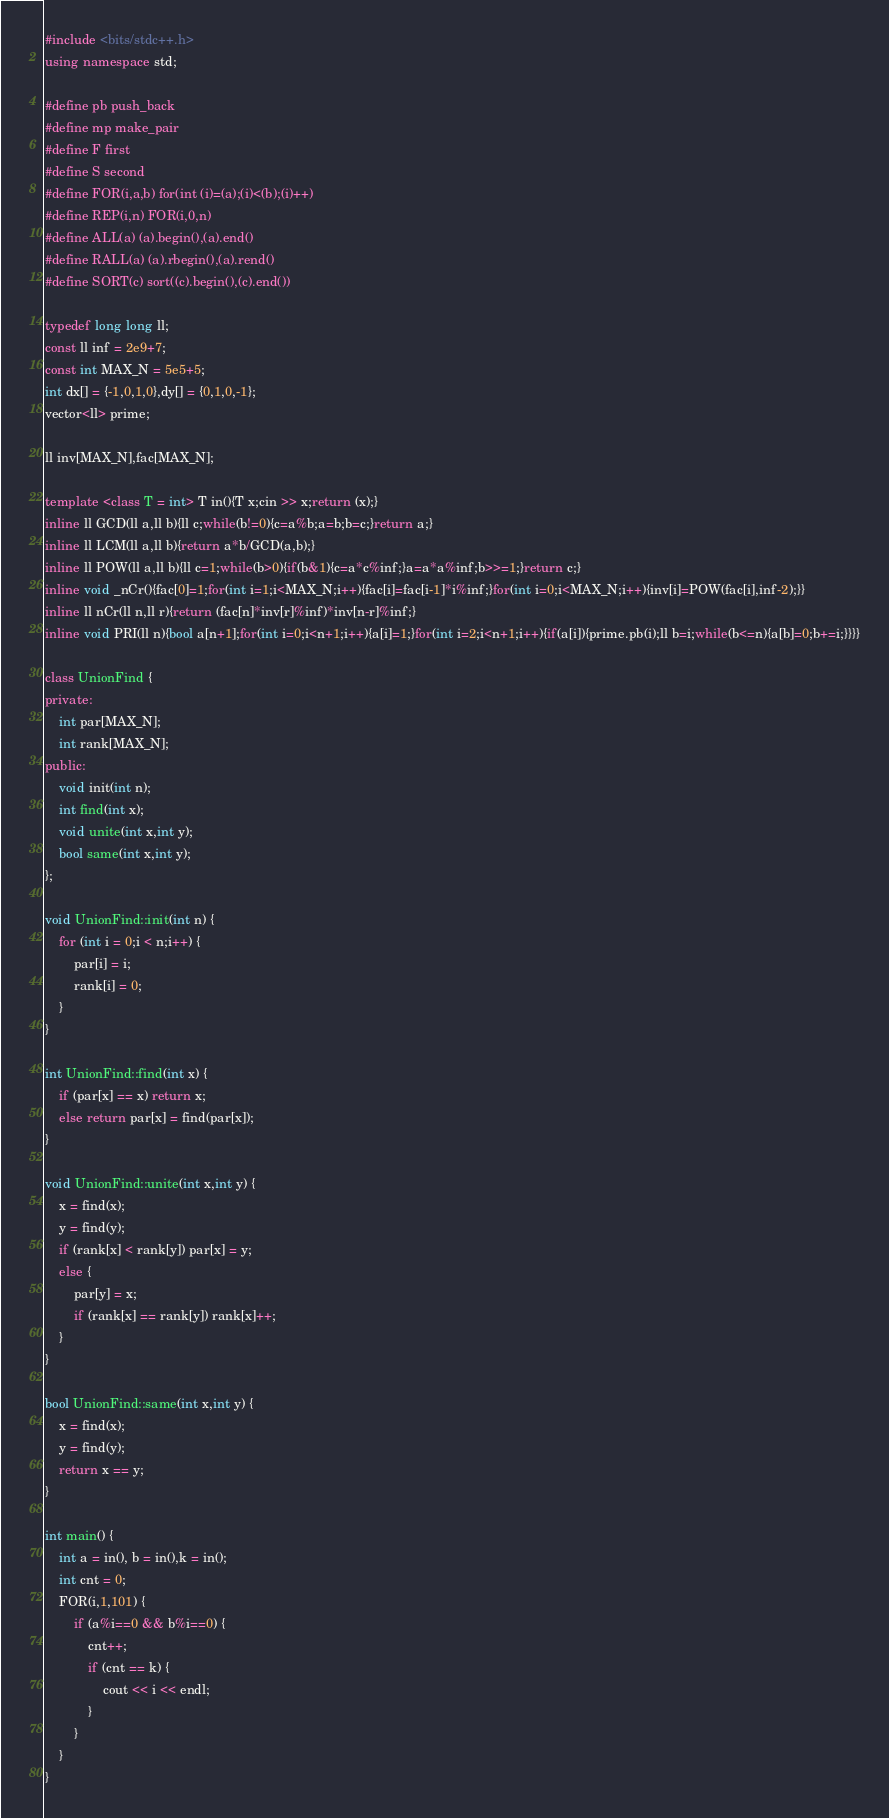<code> <loc_0><loc_0><loc_500><loc_500><_C++_>#include <bits/stdc++.h>
using namespace std;

#define pb push_back
#define mp make_pair
#define F first
#define S second
#define FOR(i,a,b) for(int (i)=(a);(i)<(b);(i)++)
#define REP(i,n) FOR(i,0,n)
#define ALL(a) (a).begin(),(a).end()
#define RALL(a) (a).rbegin(),(a).rend()
#define SORT(c) sort((c).begin(),(c).end())

typedef long long ll;
const ll inf = 2e9+7;
const int MAX_N = 5e5+5;
int dx[] = {-1,0,1,0},dy[] = {0,1,0,-1};
vector<ll> prime;

ll inv[MAX_N],fac[MAX_N];

template <class T = int> T in(){T x;cin >> x;return (x);}
inline ll GCD(ll a,ll b){ll c;while(b!=0){c=a%b;a=b;b=c;}return a;}
inline ll LCM(ll a,ll b){return a*b/GCD(a,b);}
inline ll POW(ll a,ll b){ll c=1;while(b>0){if(b&1){c=a*c%inf;}a=a*a%inf;b>>=1;}return c;}
inline void _nCr(){fac[0]=1;for(int i=1;i<MAX_N;i++){fac[i]=fac[i-1]*i%inf;}for(int i=0;i<MAX_N;i++){inv[i]=POW(fac[i],inf-2);}}
inline ll nCr(ll n,ll r){return (fac[n]*inv[r]%inf)*inv[n-r]%inf;}
inline void PRI(ll n){bool a[n+1];for(int i=0;i<n+1;i++){a[i]=1;}for(int i=2;i<n+1;i++){if(a[i]){prime.pb(i);ll b=i;while(b<=n){a[b]=0;b+=i;}}}}

class UnionFind {
private:
	int par[MAX_N];
	int rank[MAX_N];
public:
	void init(int n);
	int find(int x);
	void unite(int x,int y);
	bool same(int x,int y);
};

void UnionFind::init(int n) {
	for (int i = 0;i < n;i++) {
		par[i] = i;
		rank[i] = 0;
	}
}

int UnionFind::find(int x) {
	if (par[x] == x) return x;
	else return par[x] = find(par[x]);
}

void UnionFind::unite(int x,int y) {
	x = find(x);
	y = find(y);
	if (rank[x] < rank[y]) par[x] = y;
	else {
		par[y] = x;
		if (rank[x] == rank[y]) rank[x]++;
	}
}

bool UnionFind::same(int x,int y) {
	x = find(x);
	y = find(y);
	return x == y;
}

int main() {
	int a = in(), b = in(),k = in();
	int cnt = 0;
	FOR(i,1,101) {
		if (a%i==0 && b%i==0) {
			cnt++;
			if (cnt == k) {
				cout << i << endl;
			}
		}
	}
}</code> 